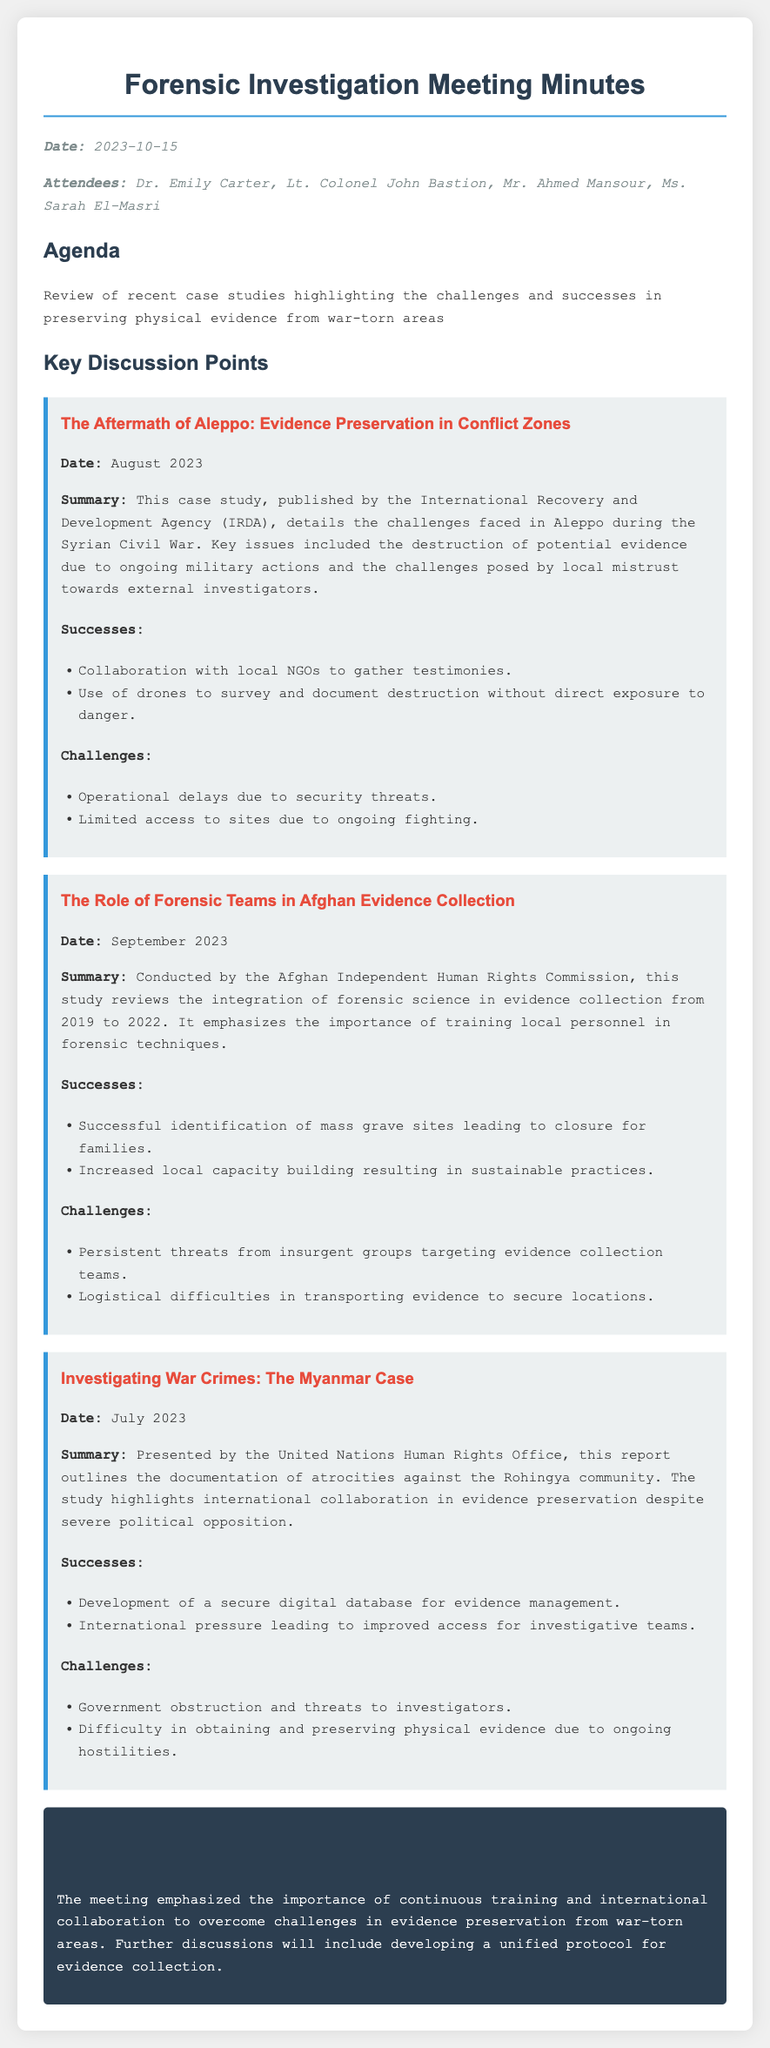What is the date of the meeting? The date of the meeting is mentioned at the start of the document.
Answer: 2023-10-15 Who published the case study about Aleppo? The case study about Aleppo was published by the International Recovery and Development Agency.
Answer: International Recovery and Development Agency (IRDA) What were the key challenges in Aleppo? Key challenges include the destruction of potential evidence and local mistrust towards external investigators, which are both stated in the summary.
Answer: Destruction of potential evidence, local mistrust What success was noted in the Afghan evidence collection study? The study notes the successful identification of mass grave sites, providing closure for families.
Answer: Successful identification of mass grave sites How many attendees were present at the meeting? The number of attendees is directly stated in the document.
Answer: Four What is emphasized as essential for overcoming evidence preservation challenges? The meeting emphasizes the importance of continuous training and international collaboration.
Answer: Continuous training and international collaboration What date was the Myanmar case study presented? The date mentioned for the Myanmar case study presentation is in the summary section.
Answer: July 2023 What is the main focus of the second case study regarding Afghan evidence collection? The main focus is on the integration of forensic science in evidence collection.
Answer: Integration of forensic science in evidence collection 